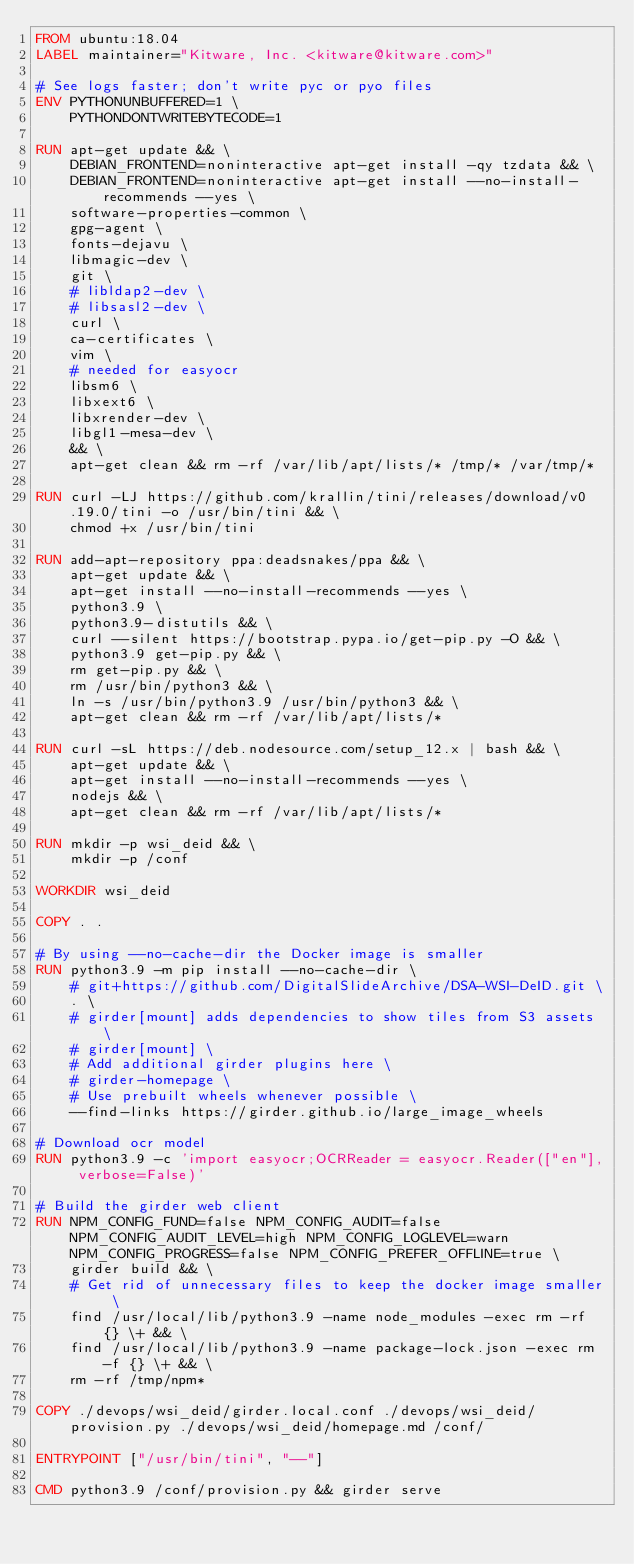<code> <loc_0><loc_0><loc_500><loc_500><_Dockerfile_>FROM ubuntu:18.04
LABEL maintainer="Kitware, Inc. <kitware@kitware.com>"

# See logs faster; don't write pyc or pyo files
ENV PYTHONUNBUFFERED=1 \
    PYTHONDONTWRITEBYTECODE=1

RUN apt-get update && \
    DEBIAN_FRONTEND=noninteractive apt-get install -qy tzdata && \
    DEBIAN_FRONTEND=noninteractive apt-get install --no-install-recommends --yes \
    software-properties-common \
    gpg-agent \
    fonts-dejavu \
    libmagic-dev \
    git \
    # libldap2-dev \
    # libsasl2-dev \
    curl \
    ca-certificates \
    vim \
    # needed for easyocr
    libsm6 \
    libxext6 \
    libxrender-dev \
    libgl1-mesa-dev \
    && \
    apt-get clean && rm -rf /var/lib/apt/lists/* /tmp/* /var/tmp/*

RUN curl -LJ https://github.com/krallin/tini/releases/download/v0.19.0/tini -o /usr/bin/tini && \
    chmod +x /usr/bin/tini

RUN add-apt-repository ppa:deadsnakes/ppa && \
    apt-get update && \
    apt-get install --no-install-recommends --yes \
    python3.9 \
    python3.9-distutils && \
    curl --silent https://bootstrap.pypa.io/get-pip.py -O && \
    python3.9 get-pip.py && \
    rm get-pip.py && \
    rm /usr/bin/python3 && \
    ln -s /usr/bin/python3.9 /usr/bin/python3 && \
    apt-get clean && rm -rf /var/lib/apt/lists/*

RUN curl -sL https://deb.nodesource.com/setup_12.x | bash && \
    apt-get update && \
    apt-get install --no-install-recommends --yes \
    nodejs && \
    apt-get clean && rm -rf /var/lib/apt/lists/*

RUN mkdir -p wsi_deid && \
    mkdir -p /conf

WORKDIR wsi_deid

COPY . .

# By using --no-cache-dir the Docker image is smaller
RUN python3.9 -m pip install --no-cache-dir \
    # git+https://github.com/DigitalSlideArchive/DSA-WSI-DeID.git \
    . \
    # girder[mount] adds dependencies to show tiles from S3 assets \
    # girder[mount] \
    # Add additional girder plugins here \
    # girder-homepage \
    # Use prebuilt wheels whenever possible \
    --find-links https://girder.github.io/large_image_wheels

# Download ocr model
RUN python3.9 -c 'import easyocr;OCRReader = easyocr.Reader(["en"], verbose=False)'

# Build the girder web client
RUN NPM_CONFIG_FUND=false NPM_CONFIG_AUDIT=false NPM_CONFIG_AUDIT_LEVEL=high NPM_CONFIG_LOGLEVEL=warn NPM_CONFIG_PROGRESS=false NPM_CONFIG_PREFER_OFFLINE=true \
    girder build && \
    # Get rid of unnecessary files to keep the docker image smaller \
    find /usr/local/lib/python3.9 -name node_modules -exec rm -rf {} \+ && \
    find /usr/local/lib/python3.9 -name package-lock.json -exec rm -f {} \+ && \
    rm -rf /tmp/npm*

COPY ./devops/wsi_deid/girder.local.conf ./devops/wsi_deid/provision.py ./devops/wsi_deid/homepage.md /conf/

ENTRYPOINT ["/usr/bin/tini", "--"]

CMD python3.9 /conf/provision.py && girder serve
</code> 